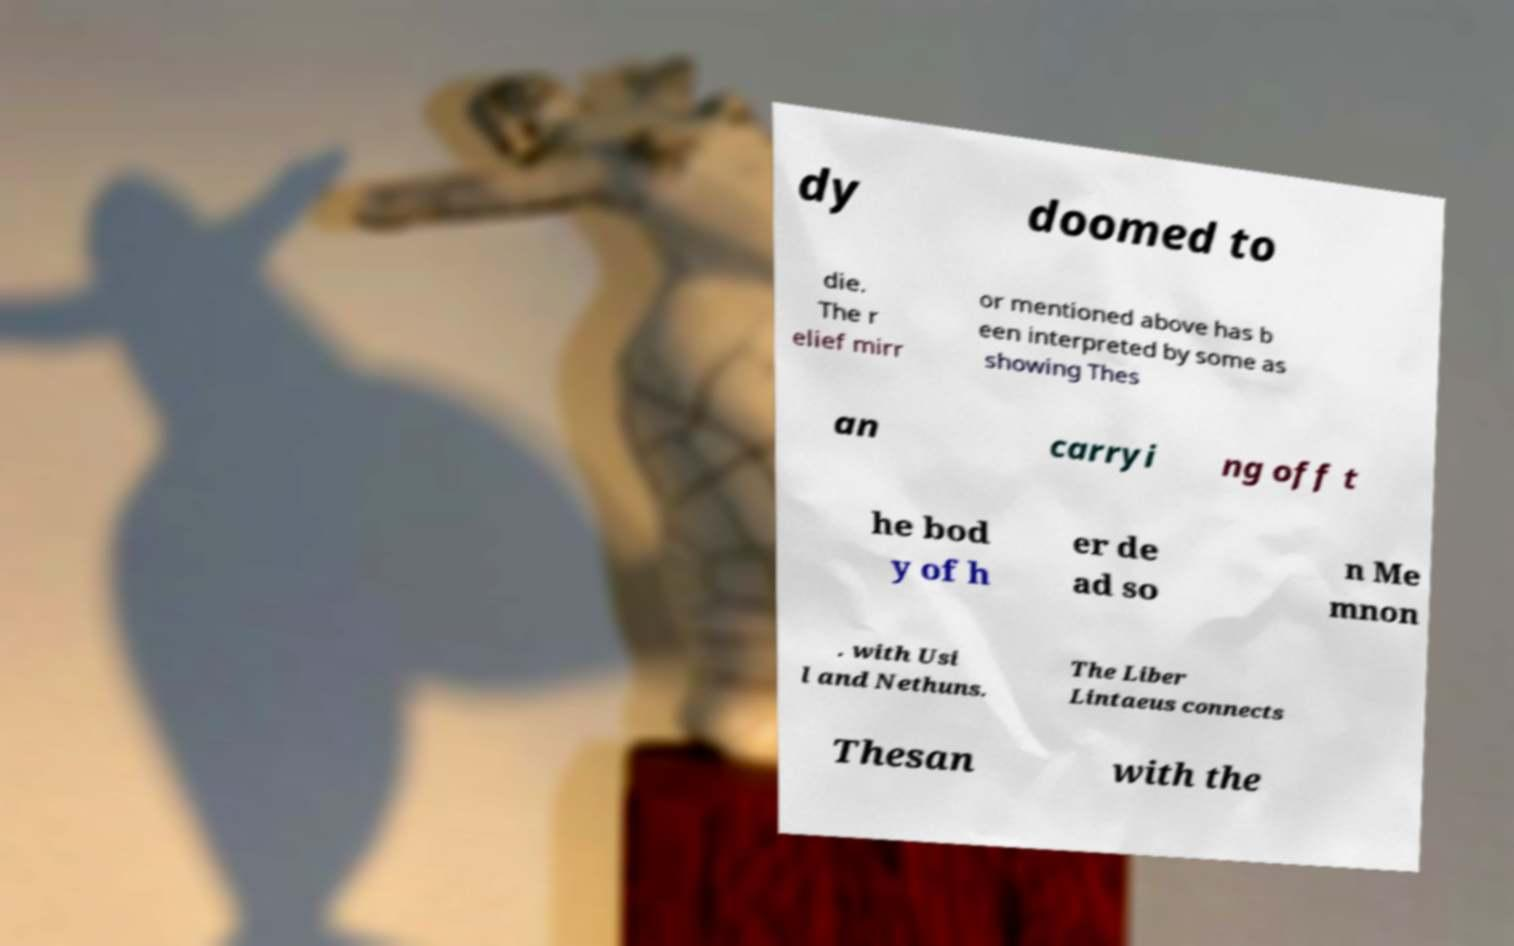What messages or text are displayed in this image? I need them in a readable, typed format. dy doomed to die. The r elief mirr or mentioned above has b een interpreted by some as showing Thes an carryi ng off t he bod y of h er de ad so n Me mnon . with Usi l and Nethuns. The Liber Lintaeus connects Thesan with the 